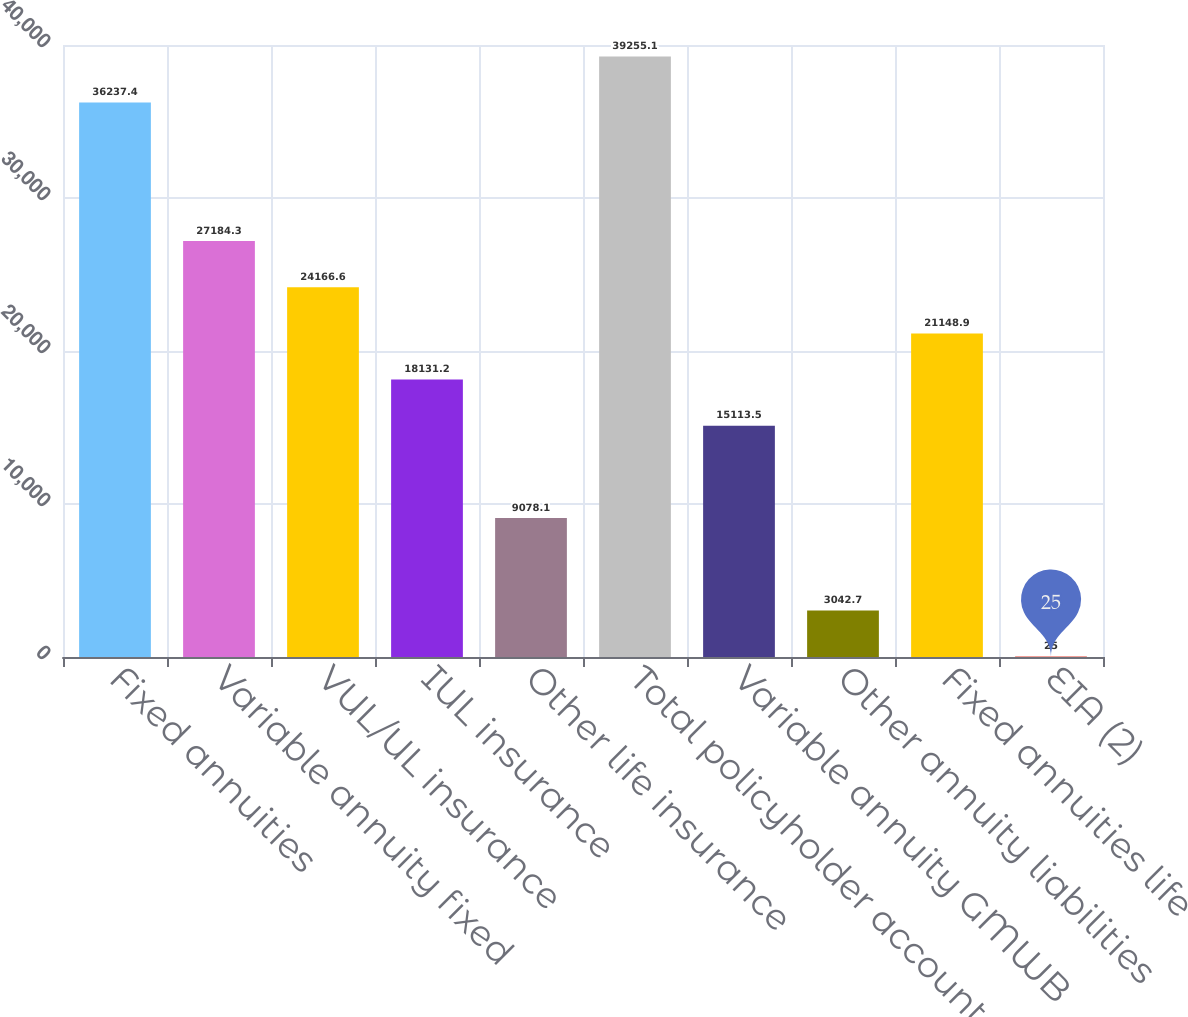Convert chart to OTSL. <chart><loc_0><loc_0><loc_500><loc_500><bar_chart><fcel>Fixed annuities<fcel>Variable annuity fixed<fcel>VUL/UL insurance<fcel>IUL insurance<fcel>Other life insurance<fcel>Total policyholder account<fcel>Variable annuity GMWB<fcel>Other annuity liabilities<fcel>Fixed annuities life<fcel>EIA (2)<nl><fcel>36237.4<fcel>27184.3<fcel>24166.6<fcel>18131.2<fcel>9078.1<fcel>39255.1<fcel>15113.5<fcel>3042.7<fcel>21148.9<fcel>25<nl></chart> 